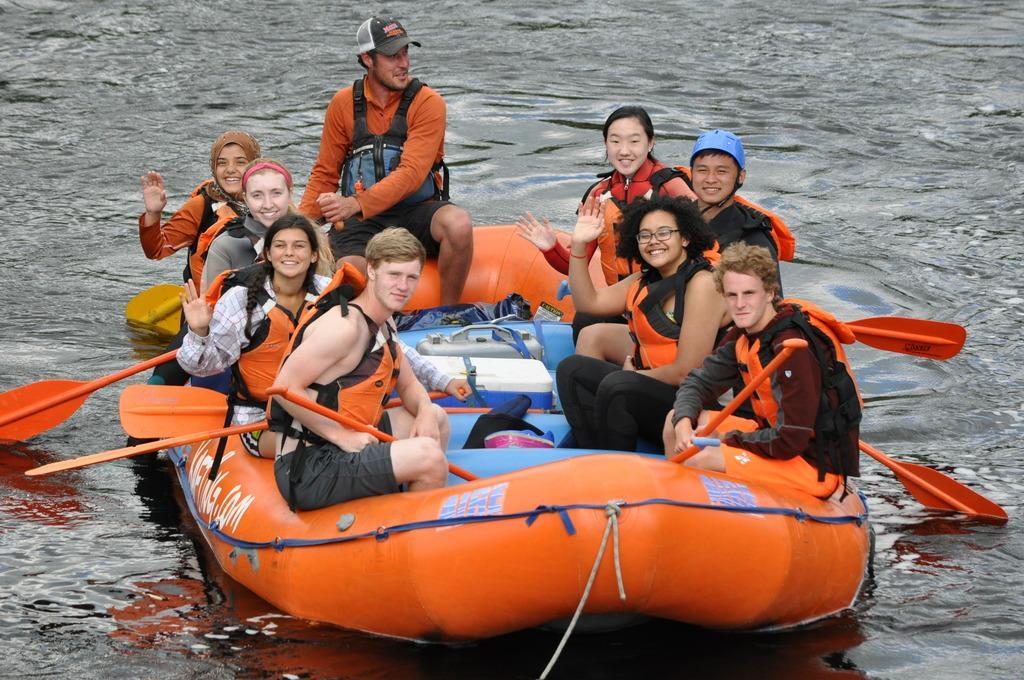How would you summarize this image in a sentence or two? In this picture I can observe a rafting boat in the middle of the picture. There are some people sitting in the boat. In the background I can observe water. 